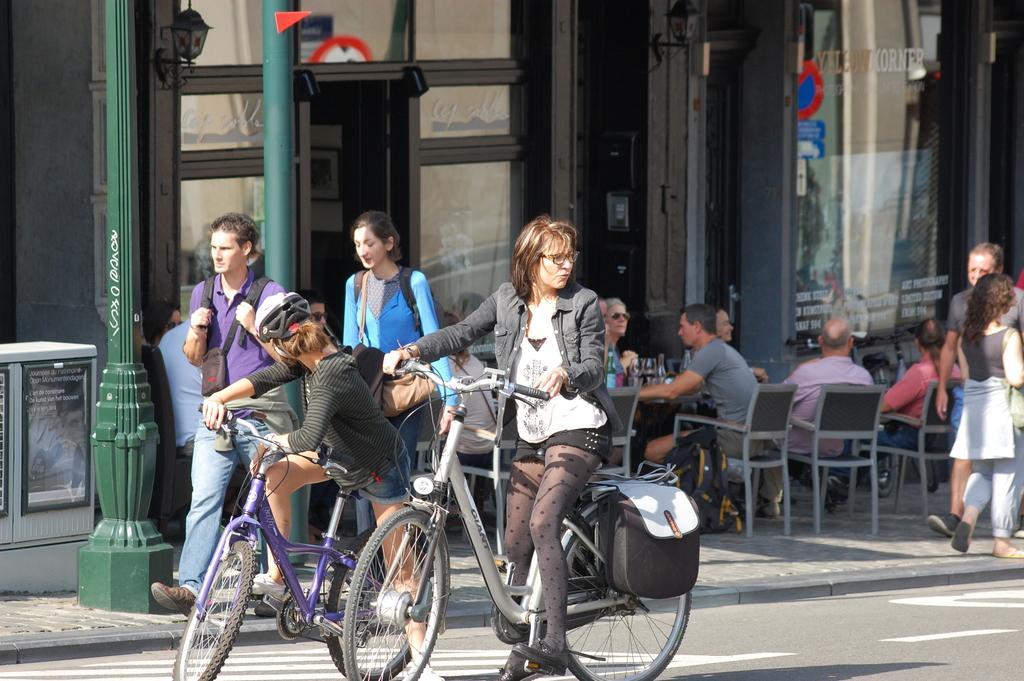Could you give a brief overview of what you see in this image? In this image, there is a building visible on the back ground and there are the poles visible on the left side , and there are the persons sitting on the chair ,in front of them there is a chair and there is a backpack on the ground and right side there are the persons walking on the ground and a woman sitting on the bi-cycle and two persons walking on the road and there are wearing a back packs. 